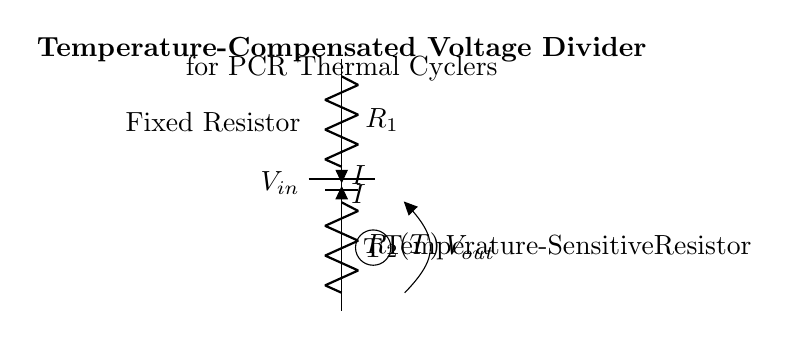What are the two types of resistors in the circuit? The circuit contains a fixed resistor labeled as R1 and a temperature-sensitive resistor labeled as R2(T).
Answer: R1 and R2(T) What is the input voltage source labeled as? The input voltage source in the circuit is labeled as V_in.
Answer: V_in What is the role of the temperature-sensitive resistor in this circuit? The temperature-sensitive resistor adjusts its resistance based on temperature changes, helping to maintain stable voltage output in varying temperatures during PCR processes.
Answer: Temperature compensation How does the current flow through the resistors? The current I flows from the positive terminal of the battery through R1, then through R2(T), before returning to the negative terminal of the battery.
Answer: I What is the output voltage represented as in the diagram? The output voltage is represented as V_out, which is taken from the junction between R1 and R2(T).
Answer: V_out What is the primary purpose of this voltage divider circuit? The primary purpose of this voltage divider is to provide a stable output voltage across R2(T) for precise temperature control in PCR thermal cyclers.
Answer: Voltage stabilization 